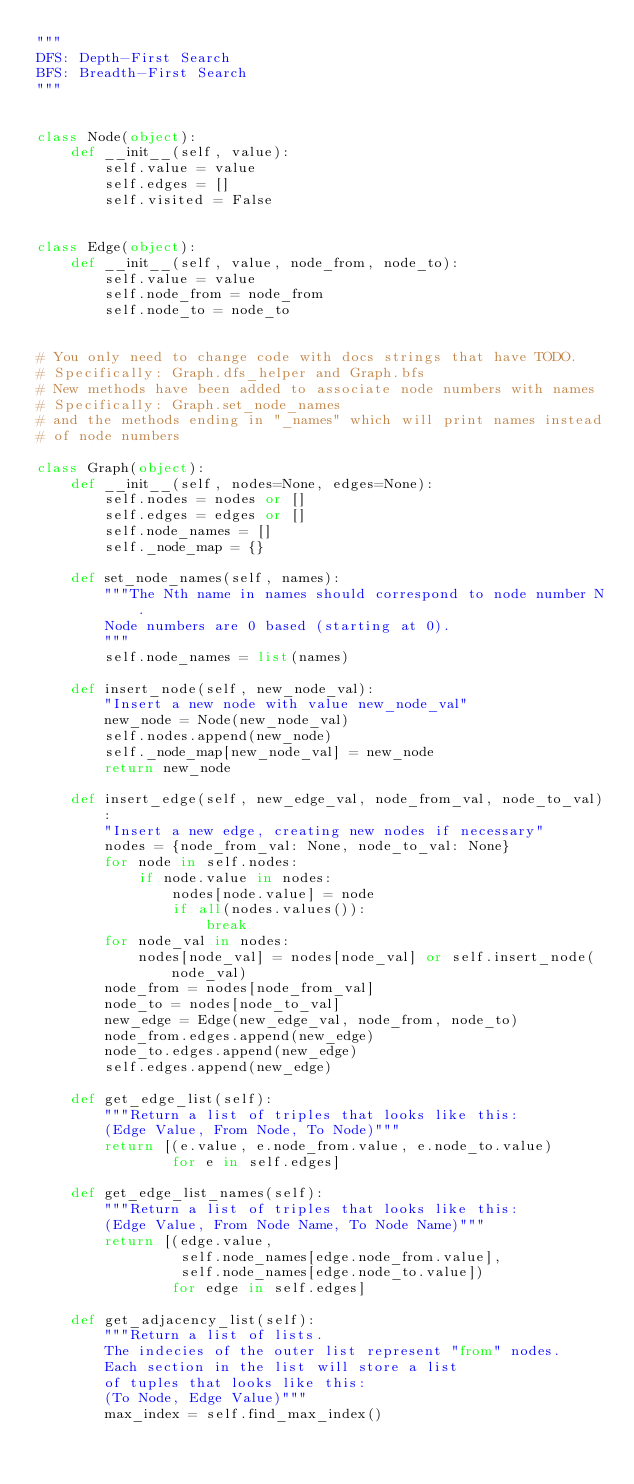<code> <loc_0><loc_0><loc_500><loc_500><_Python_>"""
DFS: Depth-First Search
BFS: Breadth-First Search
"""


class Node(object):
    def __init__(self, value):
        self.value = value
        self.edges = []
        self.visited = False


class Edge(object):
    def __init__(self, value, node_from, node_to):
        self.value = value
        self.node_from = node_from
        self.node_to = node_to


# You only need to change code with docs strings that have TODO.
# Specifically: Graph.dfs_helper and Graph.bfs
# New methods have been added to associate node numbers with names
# Specifically: Graph.set_node_names
# and the methods ending in "_names" which will print names instead
# of node numbers

class Graph(object):
    def __init__(self, nodes=None, edges=None):
        self.nodes = nodes or []
        self.edges = edges or []
        self.node_names = []
        self._node_map = {}

    def set_node_names(self, names):
        """The Nth name in names should correspond to node number N.
        Node numbers are 0 based (starting at 0).
        """
        self.node_names = list(names)

    def insert_node(self, new_node_val):
        "Insert a new node with value new_node_val"
        new_node = Node(new_node_val)
        self.nodes.append(new_node)
        self._node_map[new_node_val] = new_node
        return new_node

    def insert_edge(self, new_edge_val, node_from_val, node_to_val):
        "Insert a new edge, creating new nodes if necessary"
        nodes = {node_from_val: None, node_to_val: None}
        for node in self.nodes:
            if node.value in nodes:
                nodes[node.value] = node
                if all(nodes.values()):
                    break
        for node_val in nodes:
            nodes[node_val] = nodes[node_val] or self.insert_node(node_val)
        node_from = nodes[node_from_val]
        node_to = nodes[node_to_val]
        new_edge = Edge(new_edge_val, node_from, node_to)
        node_from.edges.append(new_edge)
        node_to.edges.append(new_edge)
        self.edges.append(new_edge)

    def get_edge_list(self):
        """Return a list of triples that looks like this:
        (Edge Value, From Node, To Node)"""
        return [(e.value, e.node_from.value, e.node_to.value)
                for e in self.edges]

    def get_edge_list_names(self):
        """Return a list of triples that looks like this:
        (Edge Value, From Node Name, To Node Name)"""
        return [(edge.value,
                 self.node_names[edge.node_from.value],
                 self.node_names[edge.node_to.value])
                for edge in self.edges]

    def get_adjacency_list(self):
        """Return a list of lists.
        The indecies of the outer list represent "from" nodes.
        Each section in the list will store a list
        of tuples that looks like this:
        (To Node, Edge Value)"""
        max_index = self.find_max_index()</code> 